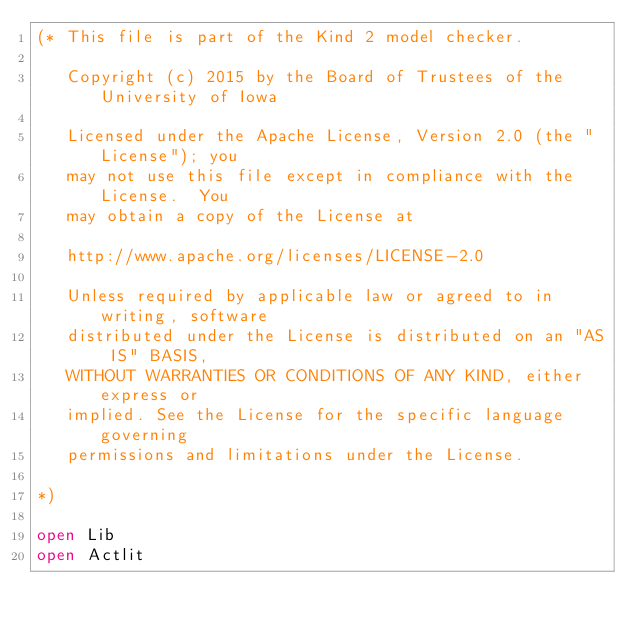Convert code to text. <code><loc_0><loc_0><loc_500><loc_500><_OCaml_>(* This file is part of the Kind 2 model checker.

   Copyright (c) 2015 by the Board of Trustees of the University of Iowa

   Licensed under the Apache License, Version 2.0 (the "License"); you
   may not use this file except in compliance with the License.  You
   may obtain a copy of the License at

   http://www.apache.org/licenses/LICENSE-2.0 

   Unless required by applicable law or agreed to in writing, software
   distributed under the License is distributed on an "AS IS" BASIS,
   WITHOUT WARRANTIES OR CONDITIONS OF ANY KIND, either express or
   implied. See the License for the specific language governing
   permissions and limitations under the License. 

*)

open Lib
open Actlit
</code> 